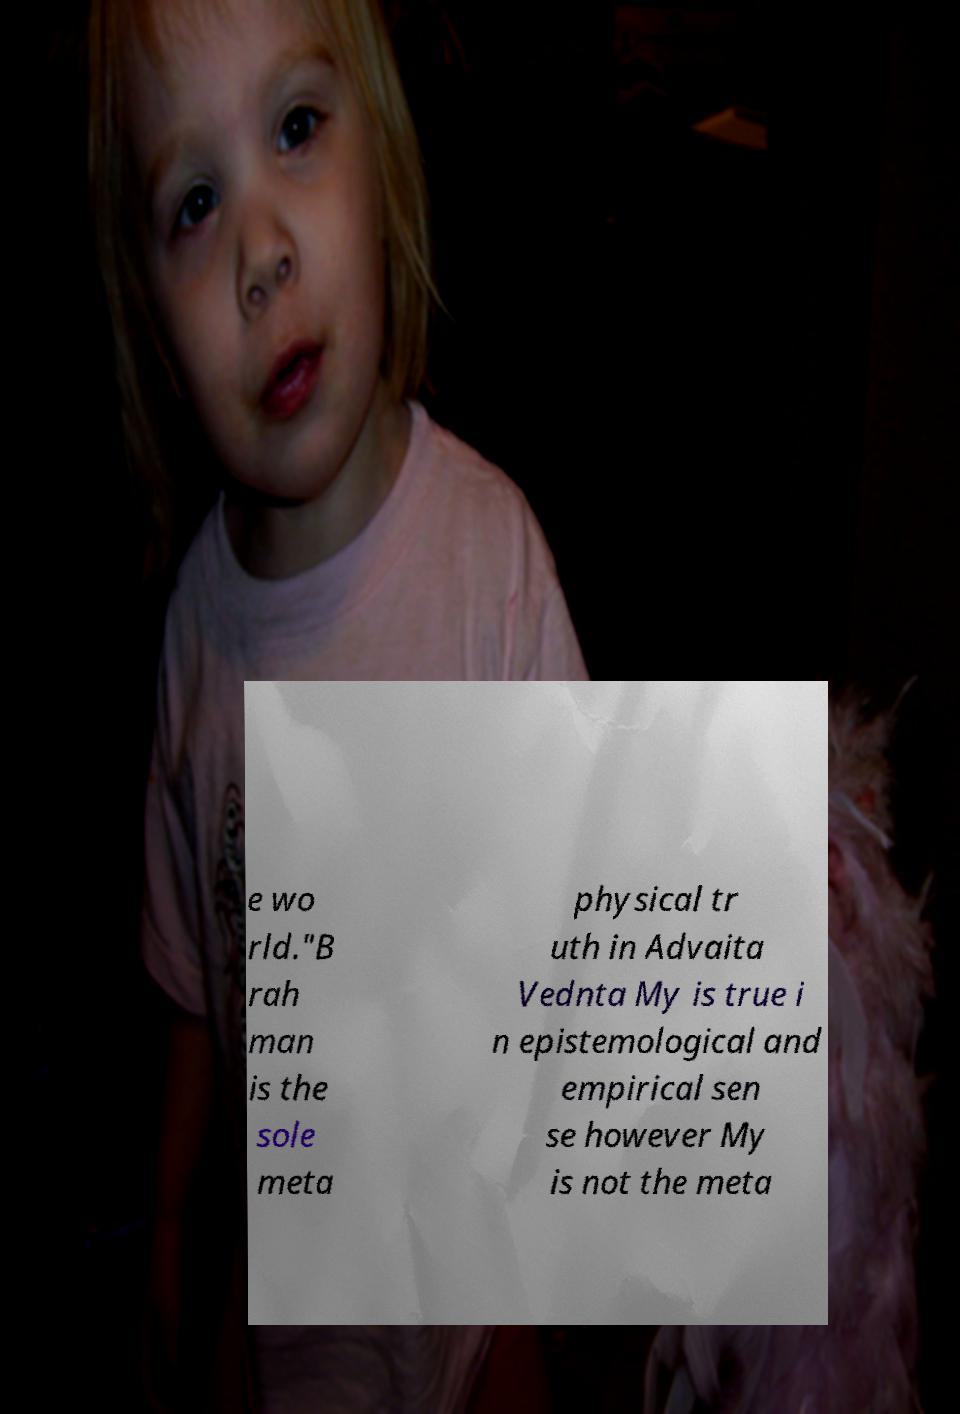For documentation purposes, I need the text within this image transcribed. Could you provide that? e wo rld."B rah man is the sole meta physical tr uth in Advaita Vednta My is true i n epistemological and empirical sen se however My is not the meta 